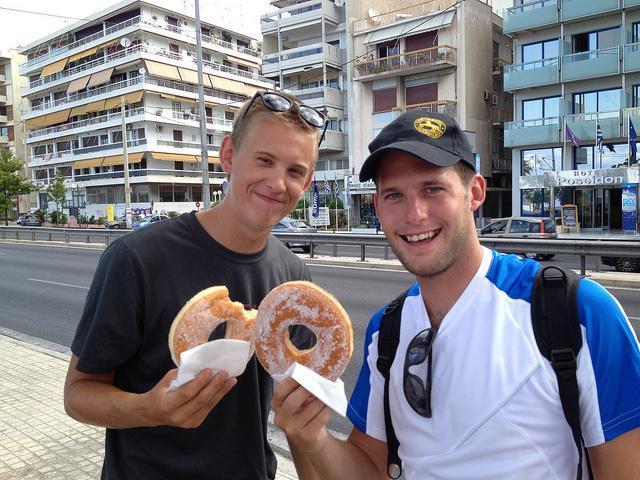How many men are pictured?
Give a very brief answer. 2. How many donuts are in the picture?
Give a very brief answer. 2. How many people are there?
Give a very brief answer. 2. 